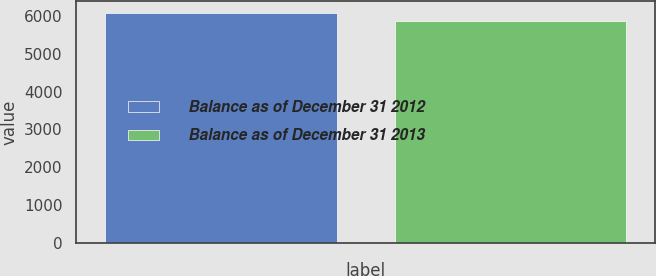<chart> <loc_0><loc_0><loc_500><loc_500><bar_chart><fcel>Balance as of December 31 2012<fcel>Balance as of December 31 2013<nl><fcel>6079<fcel>5858<nl></chart> 